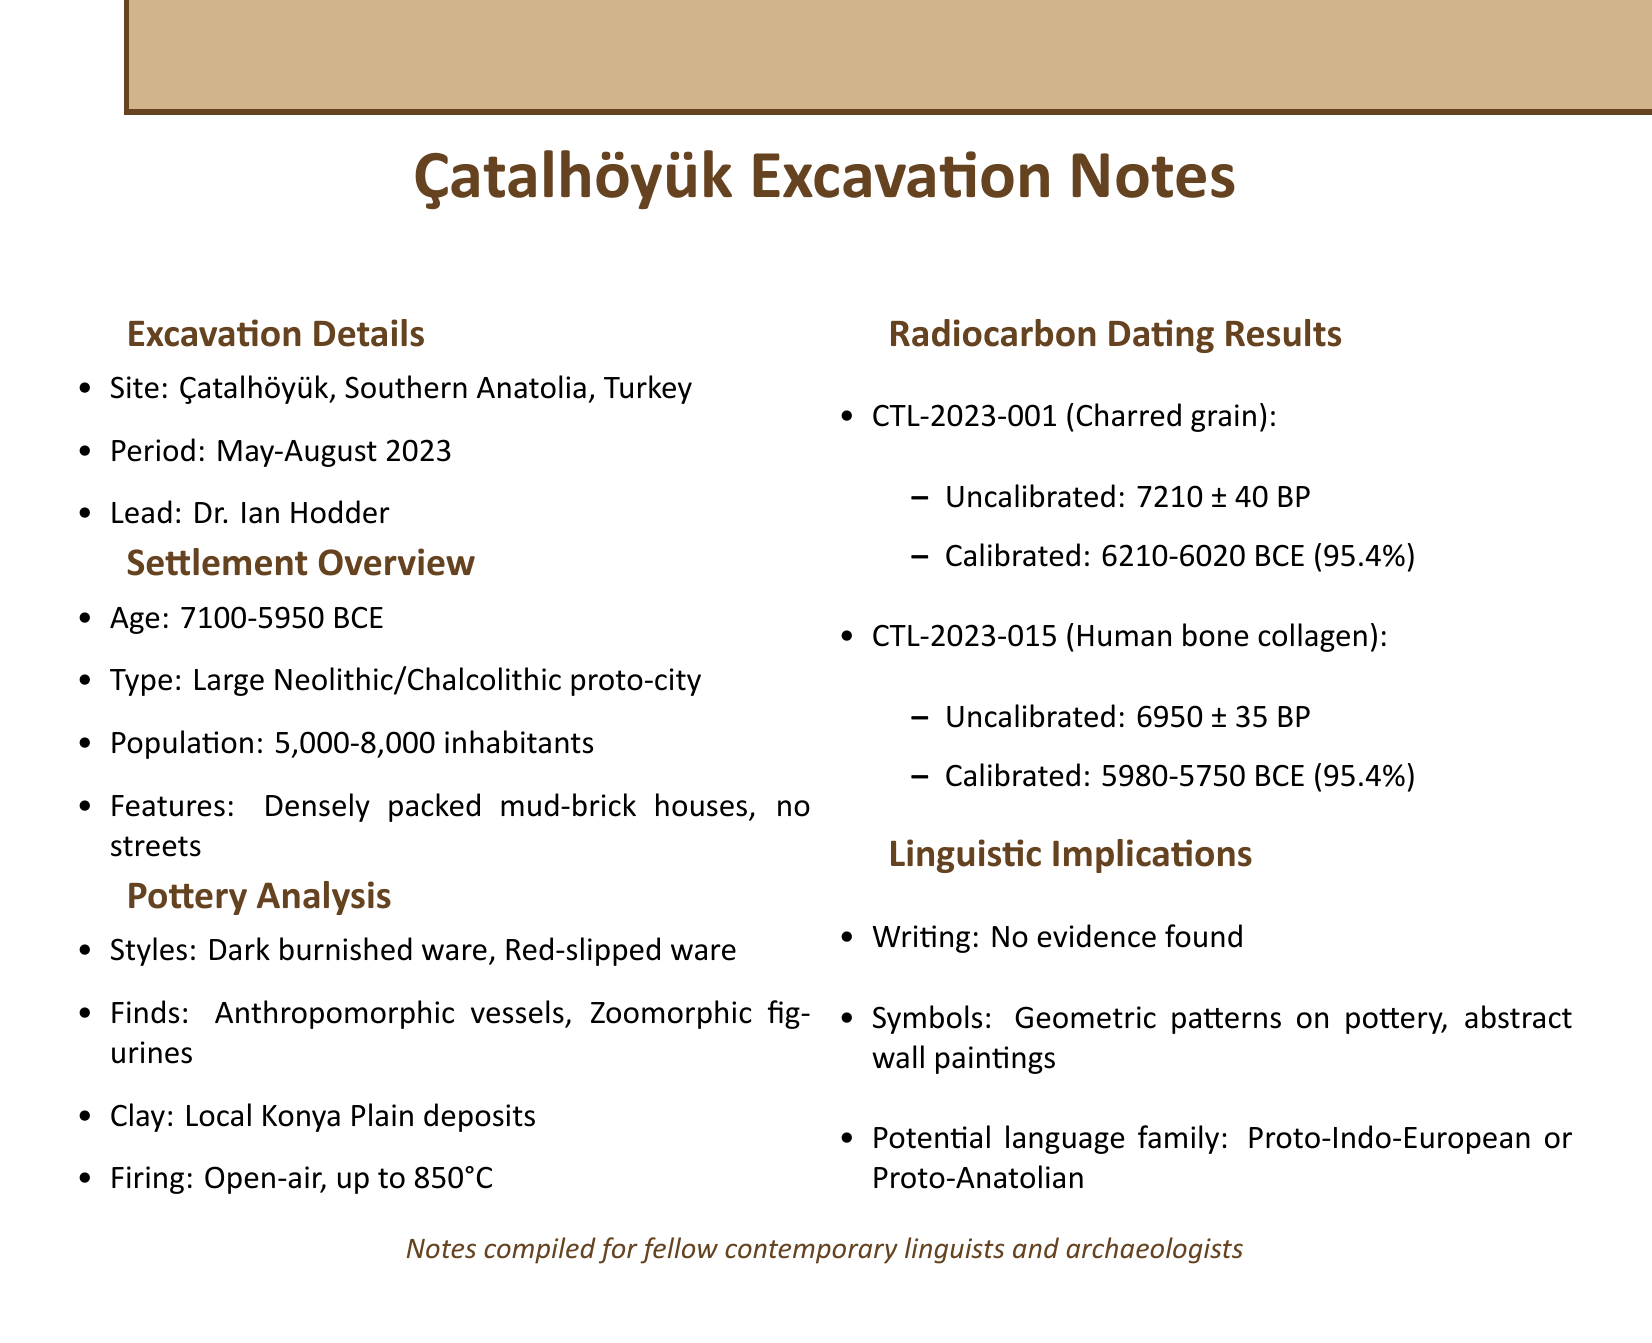What is the site name? The site name is specified in the excavation details section of the document.
Answer: Çatalhöyük Who is the lead archaeologist? The name of the lead archaeologist is mentioned in the excavation details section.
Answer: Dr. Ian Hodder What is the estimated age of the settlement? The estimated age of the settlement is found in the settlement overview section.
Answer: 7100-5950 BCE What type of pottery is dominant? The dominant styles of pottery can be found in the pottery analysis section.
Answer: Dark burnished ware, Red-slipped ware What material was sample CTL-2023-001? The material of sample CTL-2023-001 is listed in the radiocarbon dating results section.
Answer: Charred grain What is the calibrated date range for the human bone collagen? The calibrated date range for the human bone collagen is given in the radiocarbon dating results section.
Answer: 5980-5750 BCE (95.4% probability) What evidence of writing was found? The section on linguistic implications mentions the evidence of writing found (or not found).
Answer: No evidence found What are the symbolic representations mentioned in the document? The symbolic representations are detailed in the linguistic implications section.
Answer: Geometric patterns on pottery, Wall paintings with abstract designs What does the settlement's absence of streets imply? This question requires understanding the implications of the settlement's layout as described in the overview.
Answer: Early urban planning or organization 